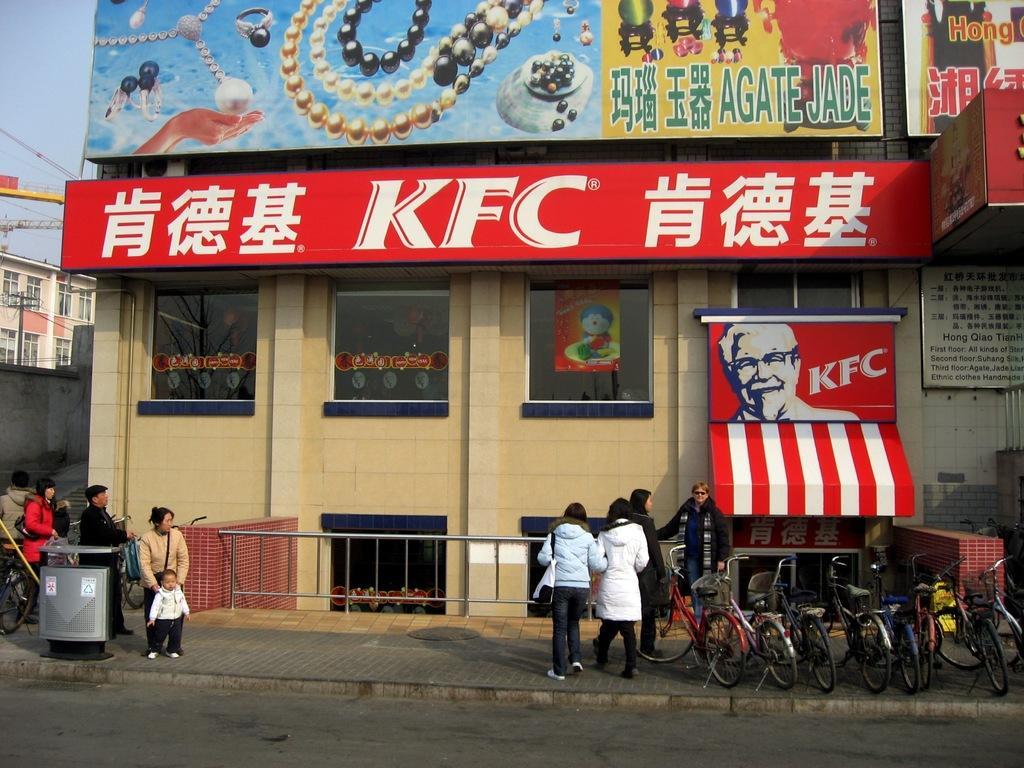Describe this image in one or two sentences. In this image there are buildings. At the bottom there is a road. On the left we can see a bin and there are people. We can see bicycles placed in a row. In the background there are wires and sky. 